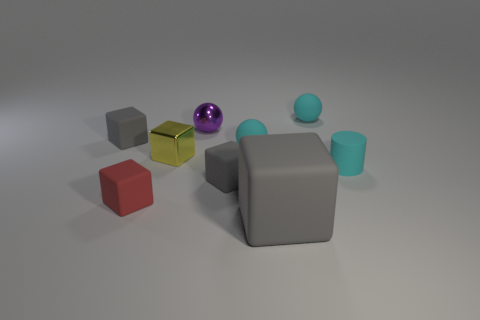Add 1 big rubber cubes. How many objects exist? 10 Subtract all small red matte blocks. How many blocks are left? 4 Subtract all gray cubes. How many cubes are left? 2 Subtract all cylinders. How many objects are left? 8 Subtract all brown cubes. Subtract all cyan spheres. How many cubes are left? 5 Subtract all red spheres. How many red cubes are left? 1 Subtract all tiny blue rubber cubes. Subtract all red cubes. How many objects are left? 8 Add 4 small purple shiny spheres. How many small purple shiny spheres are left? 5 Add 8 large brown shiny balls. How many large brown shiny balls exist? 8 Subtract 0 gray spheres. How many objects are left? 9 